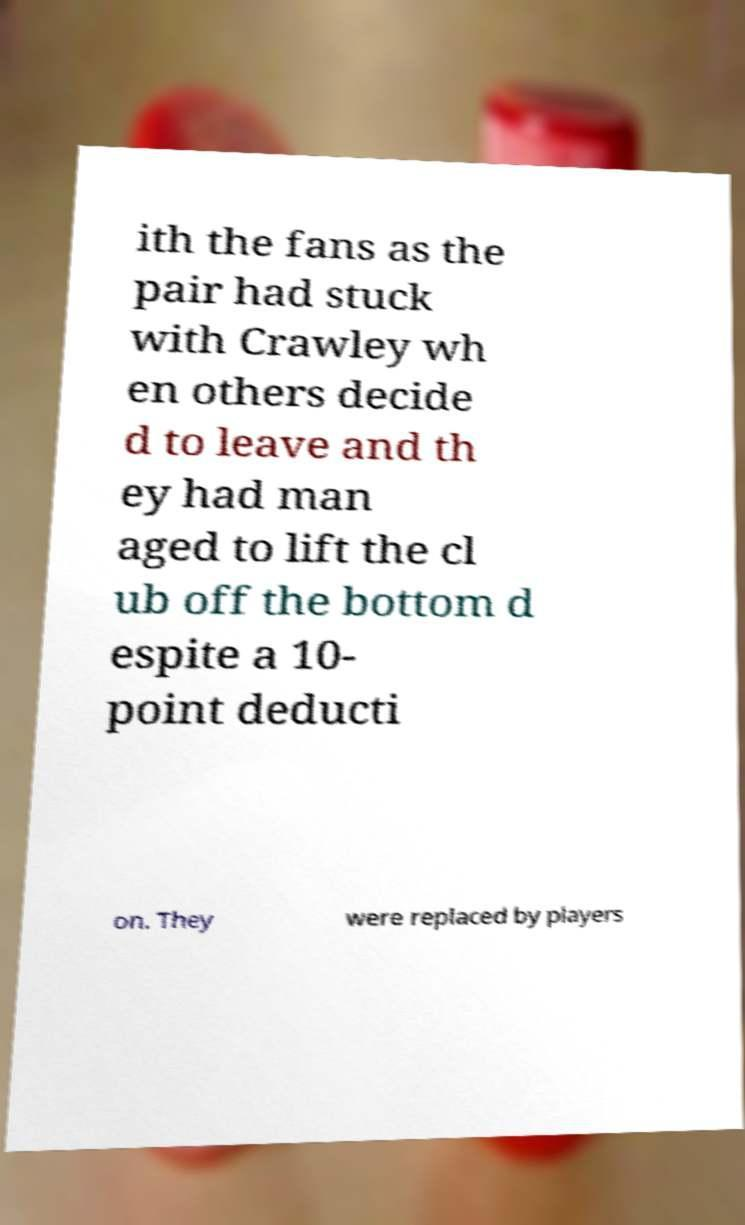Can you accurately transcribe the text from the provided image for me? ith the fans as the pair had stuck with Crawley wh en others decide d to leave and th ey had man aged to lift the cl ub off the bottom d espite a 10- point deducti on. They were replaced by players 